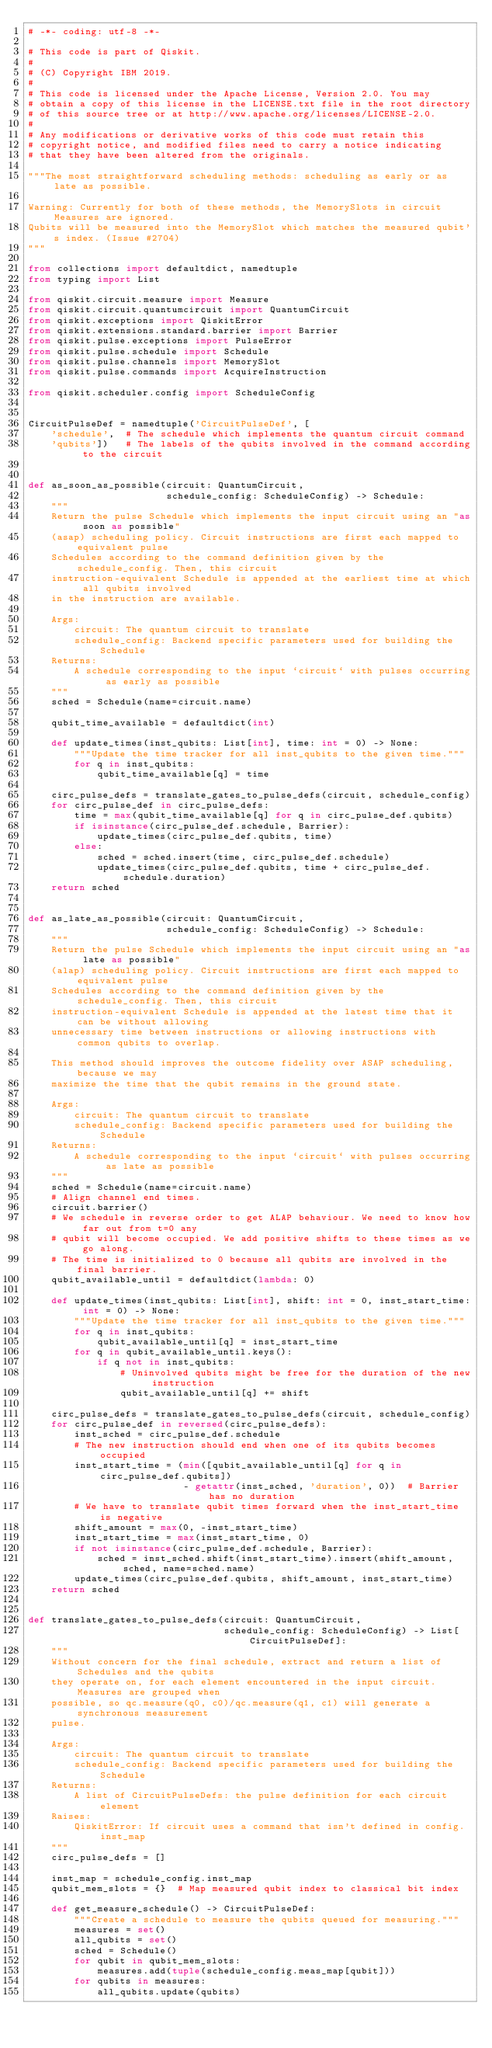<code> <loc_0><loc_0><loc_500><loc_500><_Python_># -*- coding: utf-8 -*-

# This code is part of Qiskit.
#
# (C) Copyright IBM 2019.
#
# This code is licensed under the Apache License, Version 2.0. You may
# obtain a copy of this license in the LICENSE.txt file in the root directory
# of this source tree or at http://www.apache.org/licenses/LICENSE-2.0.
#
# Any modifications or derivative works of this code must retain this
# copyright notice, and modified files need to carry a notice indicating
# that they have been altered from the originals.

"""The most straightforward scheduling methods: scheduling as early or as late as possible.

Warning: Currently for both of these methods, the MemorySlots in circuit Measures are ignored.
Qubits will be measured into the MemorySlot which matches the measured qubit's index. (Issue #2704)
"""

from collections import defaultdict, namedtuple
from typing import List

from qiskit.circuit.measure import Measure
from qiskit.circuit.quantumcircuit import QuantumCircuit
from qiskit.exceptions import QiskitError
from qiskit.extensions.standard.barrier import Barrier
from qiskit.pulse.exceptions import PulseError
from qiskit.pulse.schedule import Schedule
from qiskit.pulse.channels import MemorySlot
from qiskit.pulse.commands import AcquireInstruction

from qiskit.scheduler.config import ScheduleConfig


CircuitPulseDef = namedtuple('CircuitPulseDef', [
    'schedule',  # The schedule which implements the quantum circuit command
    'qubits'])   # The labels of the qubits involved in the command according to the circuit


def as_soon_as_possible(circuit: QuantumCircuit,
                        schedule_config: ScheduleConfig) -> Schedule:
    """
    Return the pulse Schedule which implements the input circuit using an "as soon as possible"
    (asap) scheduling policy. Circuit instructions are first each mapped to equivalent pulse
    Schedules according to the command definition given by the schedule_config. Then, this circuit
    instruction-equivalent Schedule is appended at the earliest time at which all qubits involved
    in the instruction are available.

    Args:
        circuit: The quantum circuit to translate
        schedule_config: Backend specific parameters used for building the Schedule
    Returns:
        A schedule corresponding to the input `circuit` with pulses occurring as early as possible
    """
    sched = Schedule(name=circuit.name)

    qubit_time_available = defaultdict(int)

    def update_times(inst_qubits: List[int], time: int = 0) -> None:
        """Update the time tracker for all inst_qubits to the given time."""
        for q in inst_qubits:
            qubit_time_available[q] = time

    circ_pulse_defs = translate_gates_to_pulse_defs(circuit, schedule_config)
    for circ_pulse_def in circ_pulse_defs:
        time = max(qubit_time_available[q] for q in circ_pulse_def.qubits)
        if isinstance(circ_pulse_def.schedule, Barrier):
            update_times(circ_pulse_def.qubits, time)
        else:
            sched = sched.insert(time, circ_pulse_def.schedule)
            update_times(circ_pulse_def.qubits, time + circ_pulse_def.schedule.duration)
    return sched


def as_late_as_possible(circuit: QuantumCircuit,
                        schedule_config: ScheduleConfig) -> Schedule:
    """
    Return the pulse Schedule which implements the input circuit using an "as late as possible"
    (alap) scheduling policy. Circuit instructions are first each mapped to equivalent pulse
    Schedules according to the command definition given by the schedule_config. Then, this circuit
    instruction-equivalent Schedule is appended at the latest time that it can be without allowing
    unnecessary time between instructions or allowing instructions with common qubits to overlap.

    This method should improves the outcome fidelity over ASAP scheduling, because we may
    maximize the time that the qubit remains in the ground state.

    Args:
        circuit: The quantum circuit to translate
        schedule_config: Backend specific parameters used for building the Schedule
    Returns:
        A schedule corresponding to the input `circuit` with pulses occurring as late as possible
    """
    sched = Schedule(name=circuit.name)
    # Align channel end times.
    circuit.barrier()
    # We schedule in reverse order to get ALAP behaviour. We need to know how far out from t=0 any
    # qubit will become occupied. We add positive shifts to these times as we go along.
    # The time is initialized to 0 because all qubits are involved in the final barrier.
    qubit_available_until = defaultdict(lambda: 0)

    def update_times(inst_qubits: List[int], shift: int = 0, inst_start_time: int = 0) -> None:
        """Update the time tracker for all inst_qubits to the given time."""
        for q in inst_qubits:
            qubit_available_until[q] = inst_start_time
        for q in qubit_available_until.keys():
            if q not in inst_qubits:
                # Uninvolved qubits might be free for the duration of the new instruction
                qubit_available_until[q] += shift

    circ_pulse_defs = translate_gates_to_pulse_defs(circuit, schedule_config)
    for circ_pulse_def in reversed(circ_pulse_defs):
        inst_sched = circ_pulse_def.schedule
        # The new instruction should end when one of its qubits becomes occupied
        inst_start_time = (min([qubit_available_until[q] for q in circ_pulse_def.qubits])
                           - getattr(inst_sched, 'duration', 0))  # Barrier has no duration
        # We have to translate qubit times forward when the inst_start_time is negative
        shift_amount = max(0, -inst_start_time)
        inst_start_time = max(inst_start_time, 0)
        if not isinstance(circ_pulse_def.schedule, Barrier):
            sched = inst_sched.shift(inst_start_time).insert(shift_amount, sched, name=sched.name)
        update_times(circ_pulse_def.qubits, shift_amount, inst_start_time)
    return sched


def translate_gates_to_pulse_defs(circuit: QuantumCircuit,
                                  schedule_config: ScheduleConfig) -> List[CircuitPulseDef]:
    """
    Without concern for the final schedule, extract and return a list of Schedules and the qubits
    they operate on, for each element encountered in the input circuit. Measures are grouped when
    possible, so qc.measure(q0, c0)/qc.measure(q1, c1) will generate a synchronous measurement
    pulse.

    Args:
        circuit: The quantum circuit to translate
        schedule_config: Backend specific parameters used for building the Schedule
    Returns:
        A list of CircuitPulseDefs: the pulse definition for each circuit element
    Raises:
        QiskitError: If circuit uses a command that isn't defined in config.inst_map
    """
    circ_pulse_defs = []

    inst_map = schedule_config.inst_map
    qubit_mem_slots = {}  # Map measured qubit index to classical bit index

    def get_measure_schedule() -> CircuitPulseDef:
        """Create a schedule to measure the qubits queued for measuring."""
        measures = set()
        all_qubits = set()
        sched = Schedule()
        for qubit in qubit_mem_slots:
            measures.add(tuple(schedule_config.meas_map[qubit]))
        for qubits in measures:
            all_qubits.update(qubits)</code> 